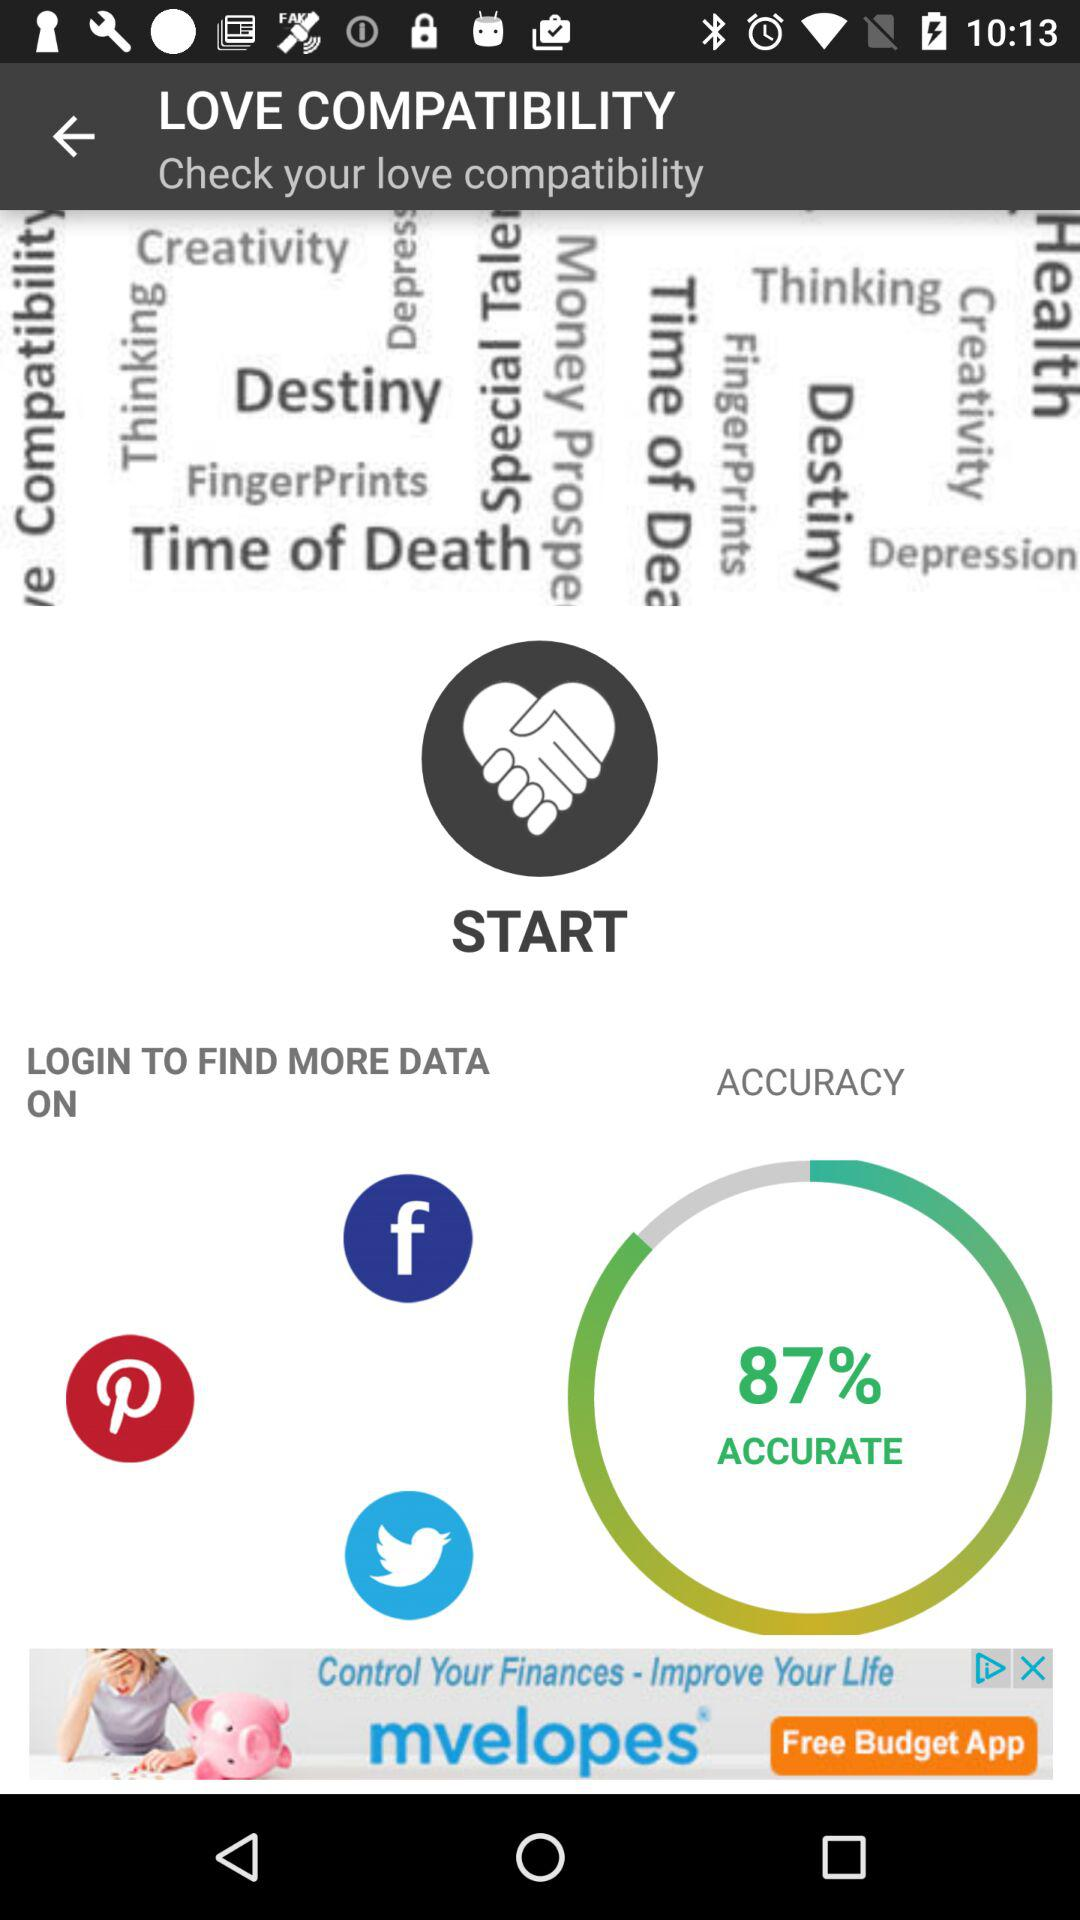Who is compatible with who?
When the provided information is insufficient, respond with <no answer>. <no answer> 